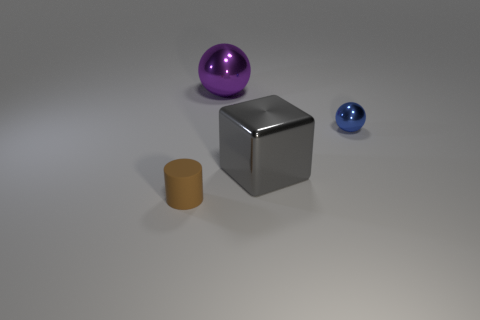Subtract 1 cubes. How many cubes are left? 0 Subtract all blue spheres. How many spheres are left? 1 Subtract 0 purple cubes. How many objects are left? 4 Subtract all cyan blocks. Subtract all yellow cylinders. How many blocks are left? 1 Subtract all purple cubes. How many blue spheres are left? 1 Subtract all brown shiny cubes. Subtract all large metal cubes. How many objects are left? 3 Add 2 brown cylinders. How many brown cylinders are left? 3 Add 2 small matte cylinders. How many small matte cylinders exist? 3 Add 3 big purple balls. How many objects exist? 7 